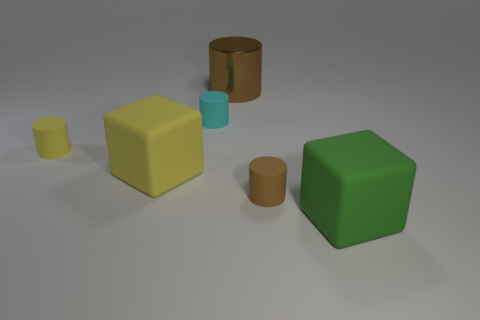Add 2 cyan matte things. How many objects exist? 8 Subtract all cubes. How many objects are left? 4 Subtract 0 brown spheres. How many objects are left? 6 Subtract all large cyan rubber blocks. Subtract all green rubber blocks. How many objects are left? 5 Add 2 yellow things. How many yellow things are left? 4 Add 2 yellow objects. How many yellow objects exist? 4 